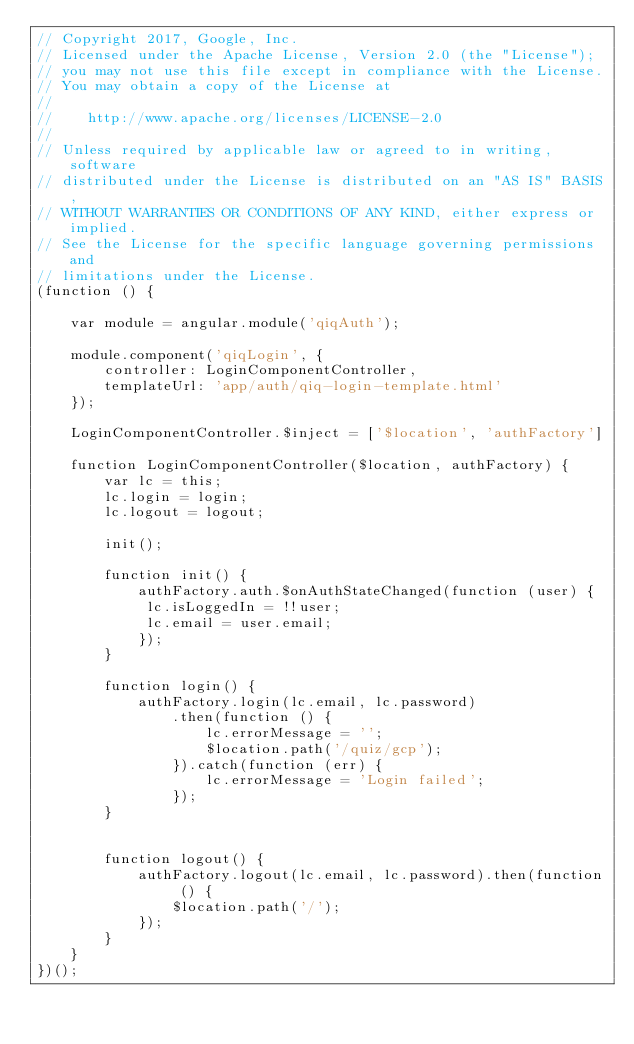<code> <loc_0><loc_0><loc_500><loc_500><_JavaScript_>// Copyright 2017, Google, Inc.
// Licensed under the Apache License, Version 2.0 (the "License");
// you may not use this file except in compliance with the License.
// You may obtain a copy of the License at
//
//    http://www.apache.org/licenses/LICENSE-2.0
//
// Unless required by applicable law or agreed to in writing, software
// distributed under the License is distributed on an "AS IS" BASIS,
// WITHOUT WARRANTIES OR CONDITIONS OF ANY KIND, either express or implied.
// See the License for the specific language governing permissions and
// limitations under the License.
(function () {

    var module = angular.module('qiqAuth');

    module.component('qiqLogin', {
        controller: LoginComponentController,
        templateUrl: 'app/auth/qiq-login-template.html'
    });

    LoginComponentController.$inject = ['$location', 'authFactory']

    function LoginComponentController($location, authFactory) {
        var lc = this;
        lc.login = login;
        lc.logout = logout;
        
        init();

        function init() {
            authFactory.auth.$onAuthStateChanged(function (user) {
             lc.isLoggedIn = !!user;
             lc.email = user.email;
            });
        }

        function login() {
            authFactory.login(lc.email, lc.password)
                .then(function () {
                    lc.errorMessage = '';
                    $location.path('/quiz/gcp');
                }).catch(function (err) {
                    lc.errorMessage = 'Login failed';
                });
        }


        function logout() {
            authFactory.logout(lc.email, lc.password).then(function () {
                $location.path('/');
            });
        }
    }
})();</code> 